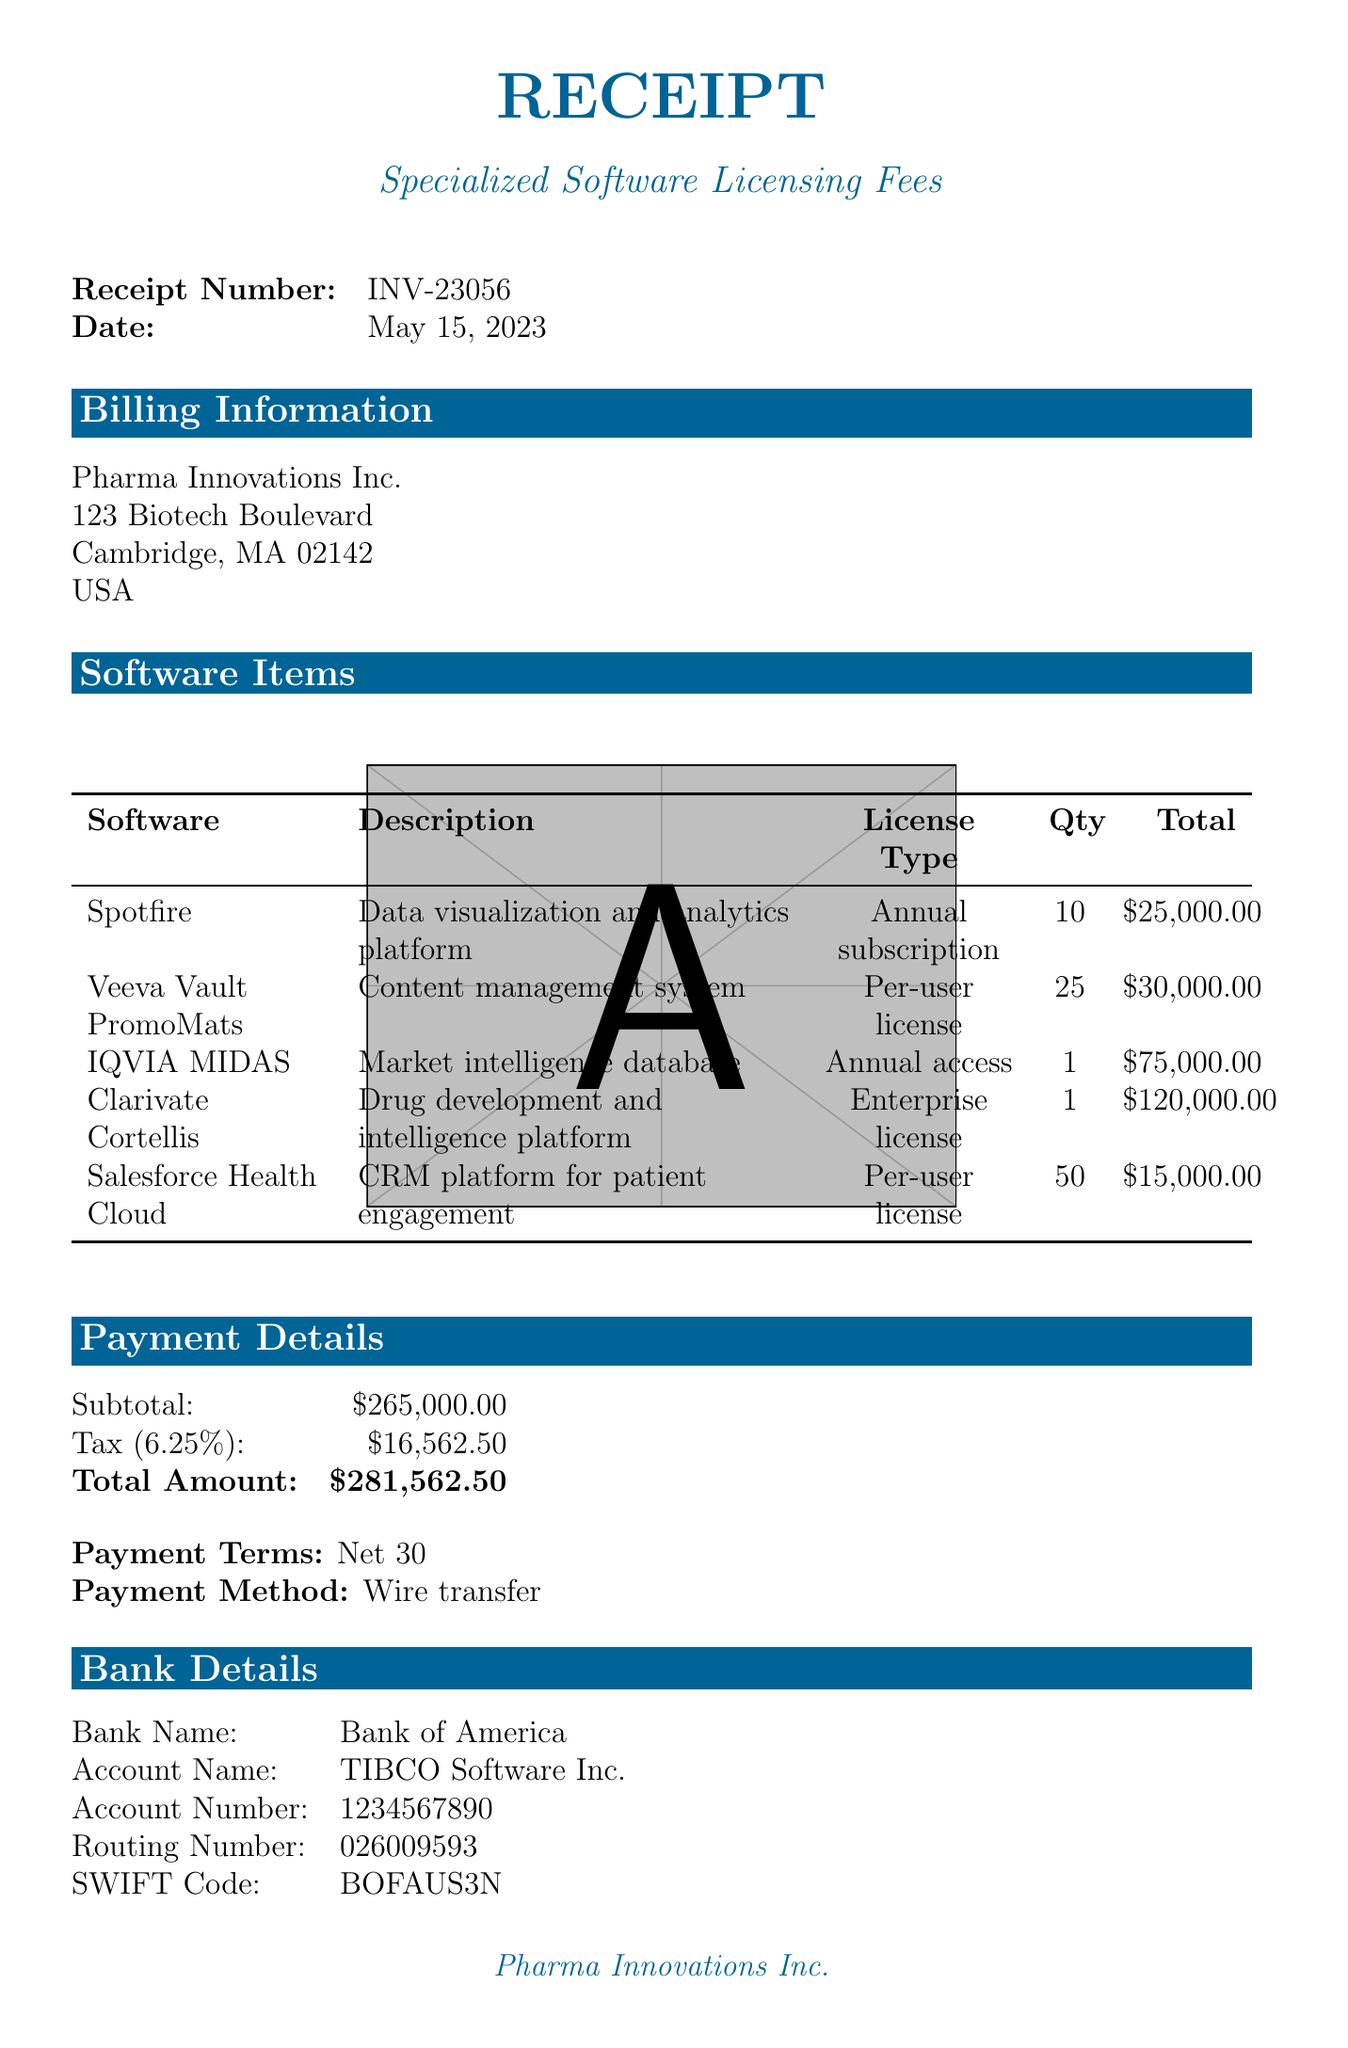What is the receipt number? The receipt number is listed at the top of the document, under "Receipt Number."
Answer: INV-23056 What is the date of the receipt? The date of the receipt is stated prominently in the document after the receipt number.
Answer: May 15, 2023 How many licenses of Spotfire were purchased? The quantity of Spotfire licenses is mentioned in the "Software Items" section of the document.
Answer: 10 What is the total amount due? The total amount is highlighted in the "Payment Details" section, summarizing the charges.
Answer: $281,562.50 Which software is used for clinical trial data? The software used for clinical trial data is specified in the description of the Spotfire entry.
Answer: Spotfire What type of license does IQVIA MIDAS have? The license type for IQVIA MIDAS is detailed in its entry in the "Software Items" section.
Answer: Annual access What is the tax rate applied to the subtotal? The tax rate is indicated in the "Payment Details" section of the receipt.
Answer: 6.25% What payment method is specified in the document? The payment method is outlined in the "Payment Details" section.
Answer: Wire transfer Which bank is listed for payment? The bank name for payments is provided in the "Bank Details" section of the receipt.
Answer: Bank of America 